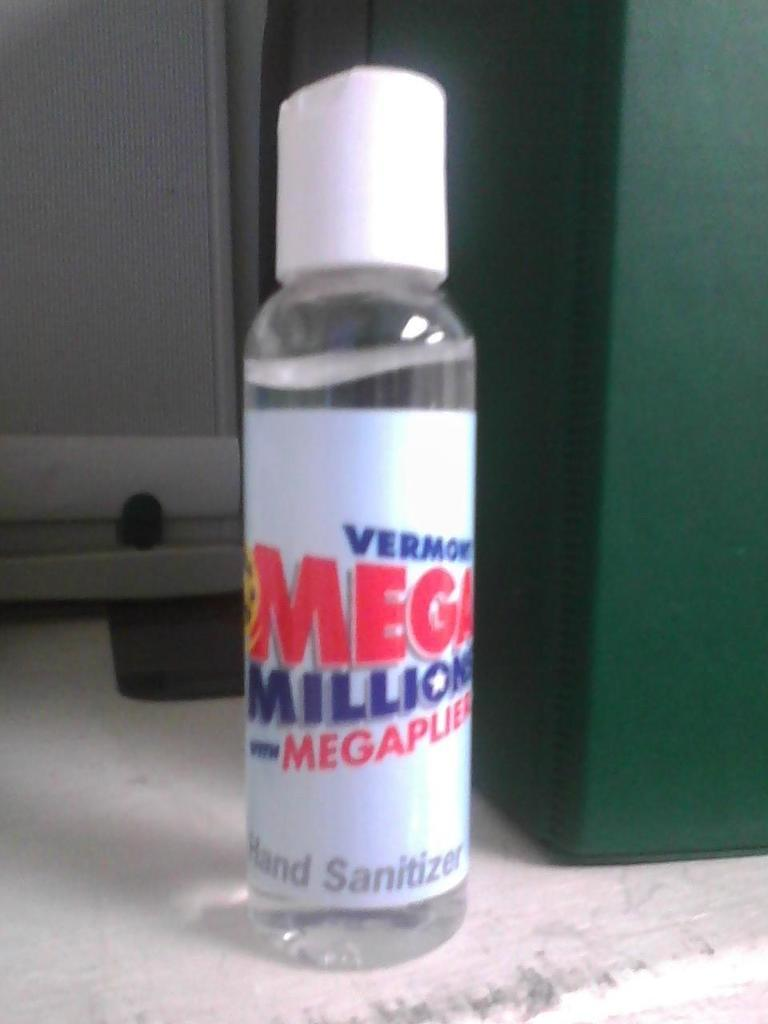<image>
Provide a brief description of the given image. bottle of white label vermont mega millions hand sanitizer next to something green 